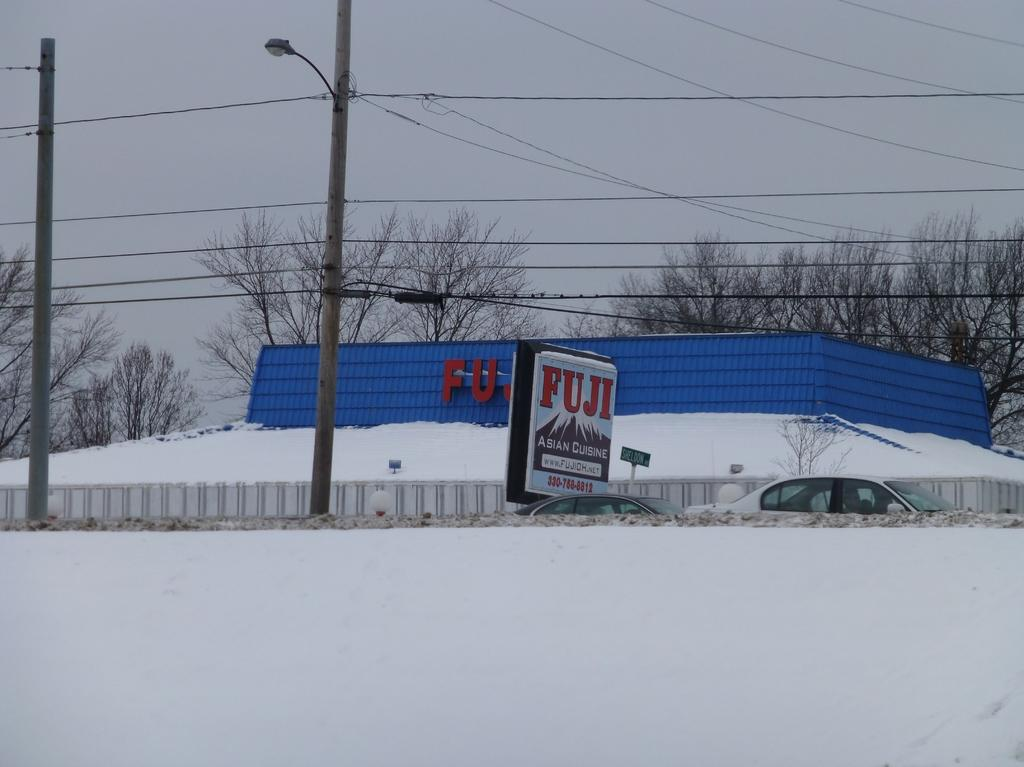<image>
Create a compact narrative representing the image presented. A Fuji sign in front of a Fuji building is slightly crooked. 